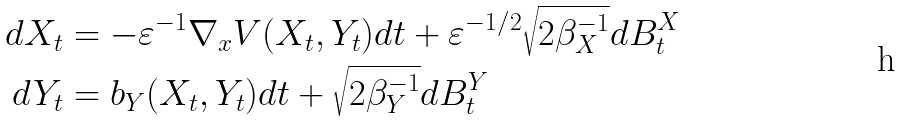<formula> <loc_0><loc_0><loc_500><loc_500>d X _ { t } & = - \varepsilon ^ { - 1 } \nabla _ { x } V ( X _ { t } , Y _ { t } ) d t + { \varepsilon } ^ { - 1 / 2 } \sqrt { 2 { \beta _ { X } ^ { - 1 } } } d B ^ { X } _ { t } \\ d Y _ { t } & = b _ { Y } ( X _ { t } , Y _ { t } ) d t + \sqrt { 2 \beta _ { Y } ^ { - 1 } } d B ^ { Y } _ { t }</formula> 